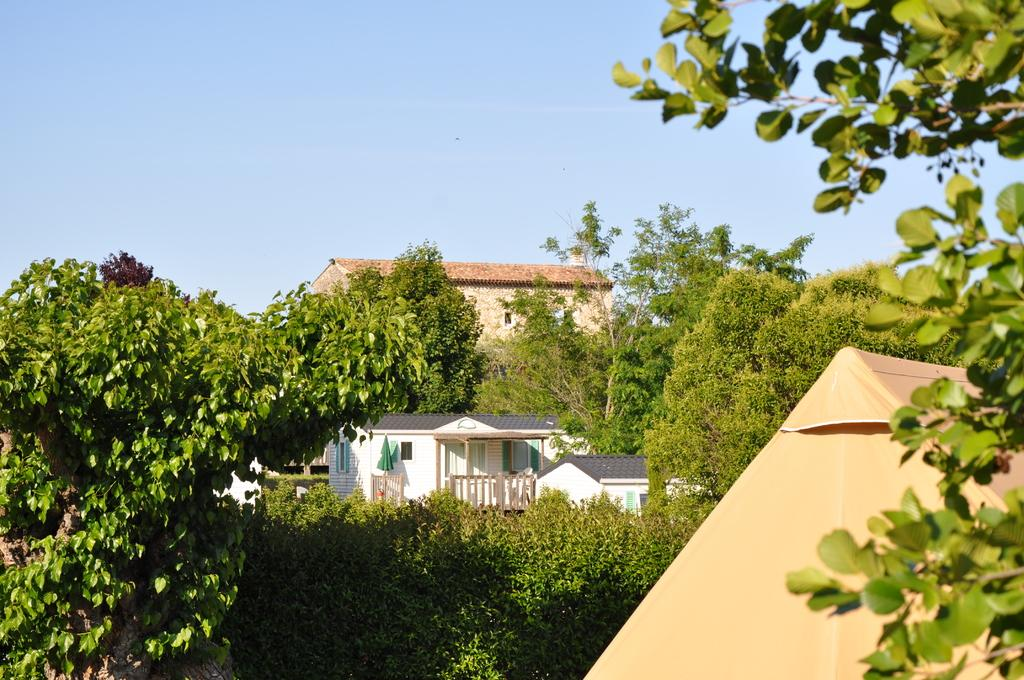What type of vegetation is present in the image? There are many trees in the image. What type of structures can be seen in the image? There are houses in the image. What is visible in the background of the image? The sky is visible in the background of the image. What type of advice can be seen being given by the trees in the image? There is no advice being given by the trees in the image, as trees do not have the ability to give advice. 